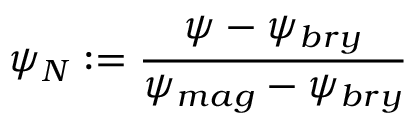Convert formula to latex. <formula><loc_0><loc_0><loc_500><loc_500>\psi _ { N } \colon = \frac { \psi - \psi _ { b r y } } { \psi _ { m a g } - \psi _ { b r y } }</formula> 